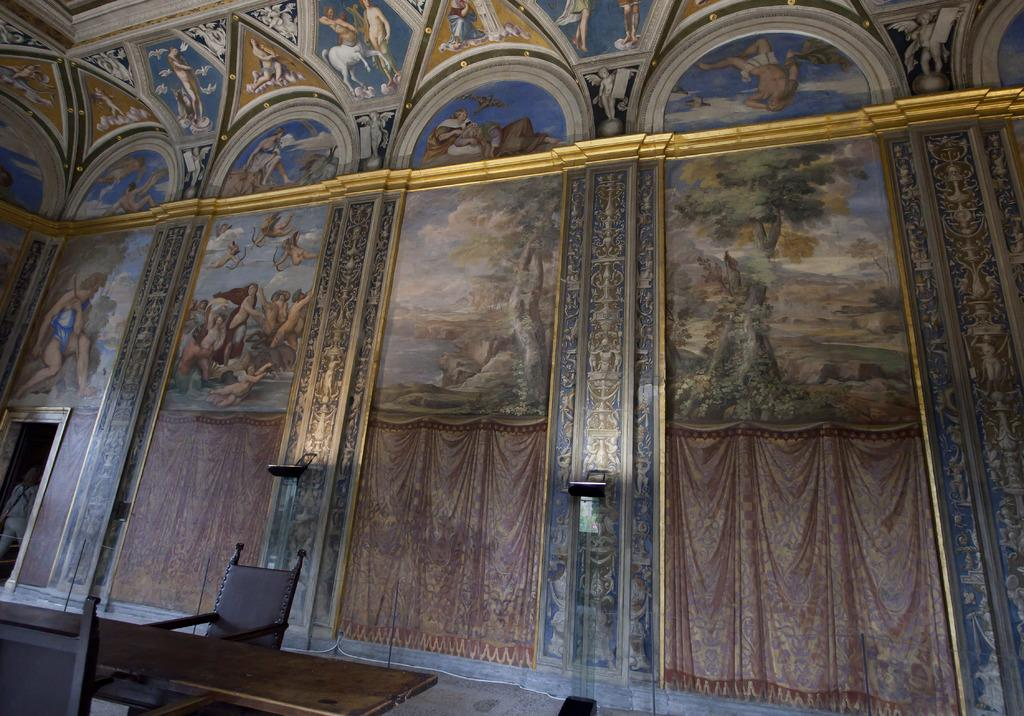What can be seen on the wall in the image? There are paintings on the wall in the image. What else is present in the image besides the paintings? There are objects and a table and chairs on the left side bottom of the image. Can you describe the person in the image? There is a person in the image, but their specific appearance or actions are not mentioned in the provided facts. What is the person's relationship to the objects and paintings in the image? The person's relationship to the objects and paintings is not mentioned in the provided facts. What type of quiver is the person holding in the image? There is no quiver present in the image. How does the person roll the objects across the table in the image? There is no information about the person rolling objects or any objects being rolled in the image. 